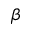Convert formula to latex. <formula><loc_0><loc_0><loc_500><loc_500>\beta</formula> 